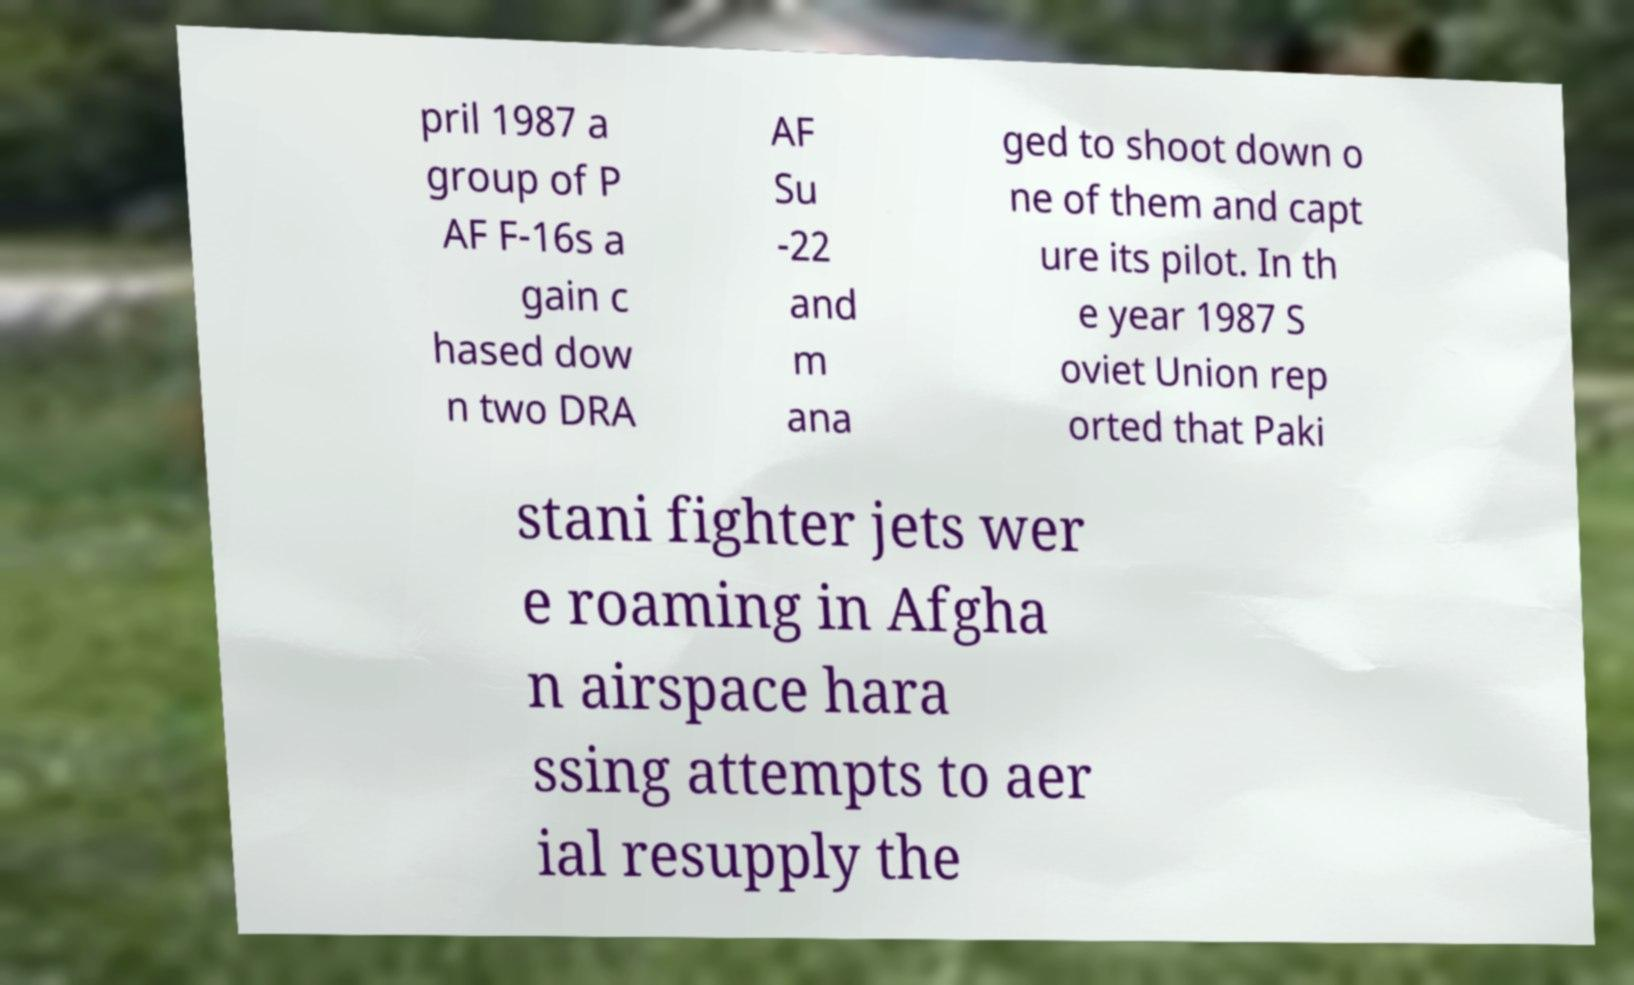I need the written content from this picture converted into text. Can you do that? pril 1987 a group of P AF F-16s a gain c hased dow n two DRA AF Su -22 and m ana ged to shoot down o ne of them and capt ure its pilot. In th e year 1987 S oviet Union rep orted that Paki stani fighter jets wer e roaming in Afgha n airspace hara ssing attempts to aer ial resupply the 